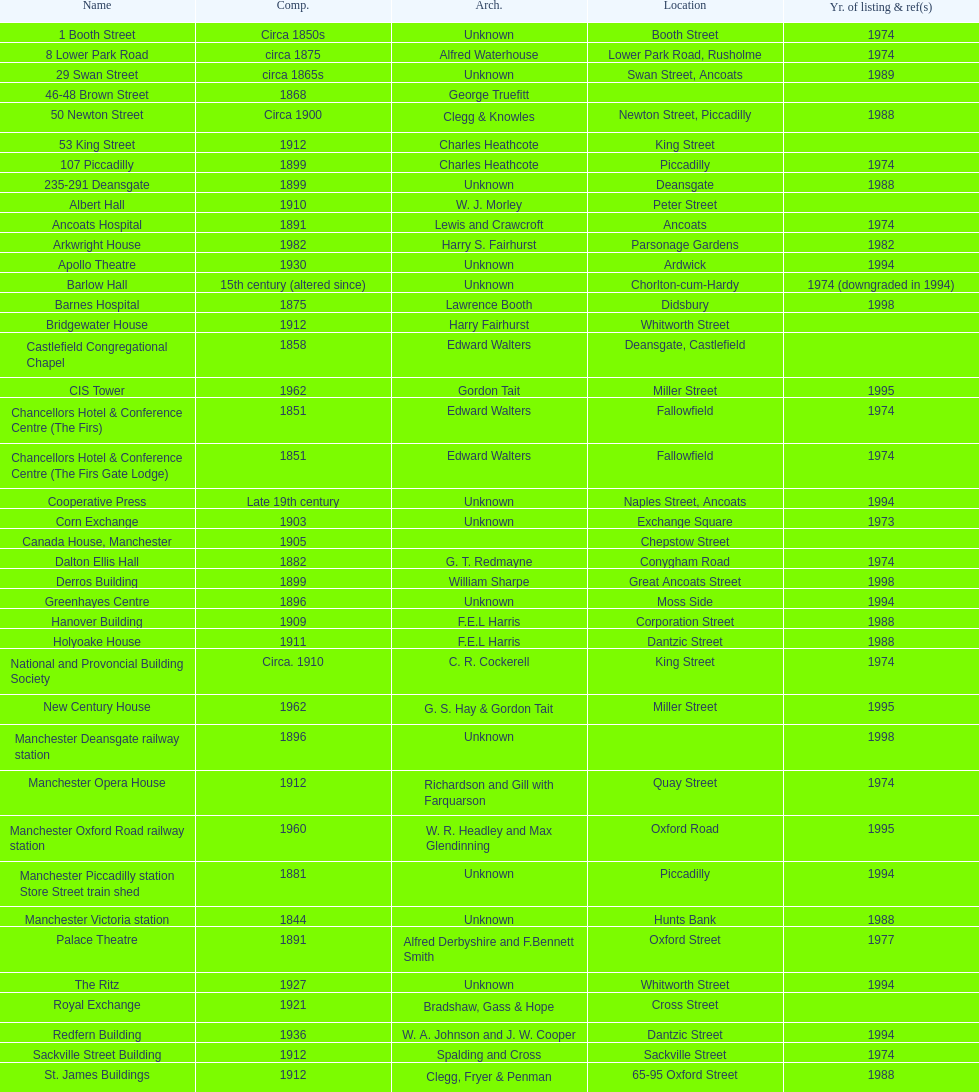What is the number of buildings without a listed image? 11. 